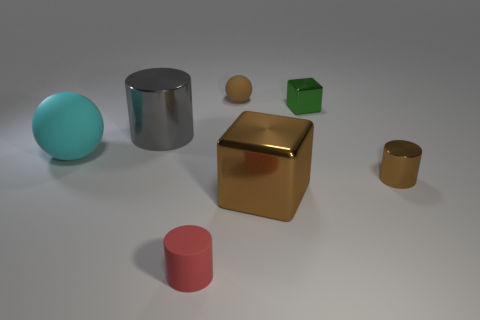Add 2 small blocks. How many objects exist? 9 Subtract all small brown metallic cylinders. How many cylinders are left? 2 Subtract all brown cylinders. How many cylinders are left? 2 Subtract all cubes. How many objects are left? 5 Subtract 1 cylinders. How many cylinders are left? 2 Subtract 0 purple cubes. How many objects are left? 7 Subtract all gray spheres. Subtract all red cubes. How many spheres are left? 2 Subtract all red spheres. How many gray cylinders are left? 1 Subtract all green metallic blocks. Subtract all metal cylinders. How many objects are left? 4 Add 2 big gray cylinders. How many big gray cylinders are left? 3 